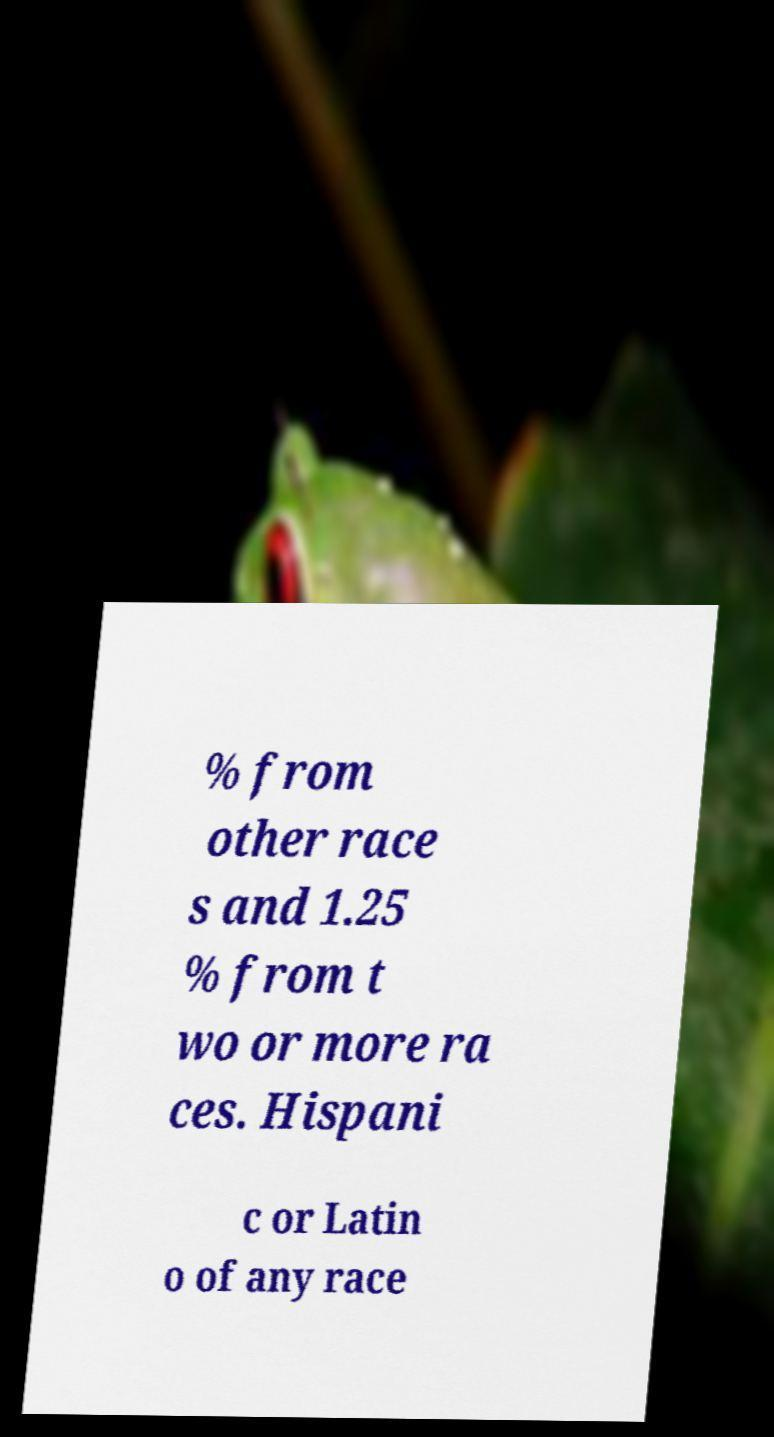There's text embedded in this image that I need extracted. Can you transcribe it verbatim? % from other race s and 1.25 % from t wo or more ra ces. Hispani c or Latin o of any race 